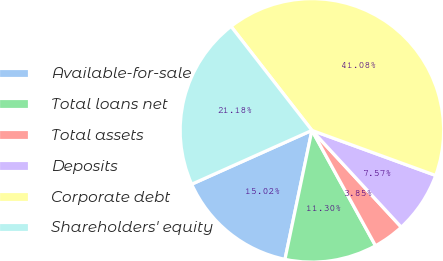Convert chart. <chart><loc_0><loc_0><loc_500><loc_500><pie_chart><fcel>Available-for-sale<fcel>Total loans net<fcel>Total assets<fcel>Deposits<fcel>Corporate debt<fcel>Shareholders' equity<nl><fcel>15.02%<fcel>11.3%<fcel>3.85%<fcel>7.57%<fcel>41.08%<fcel>21.18%<nl></chart> 